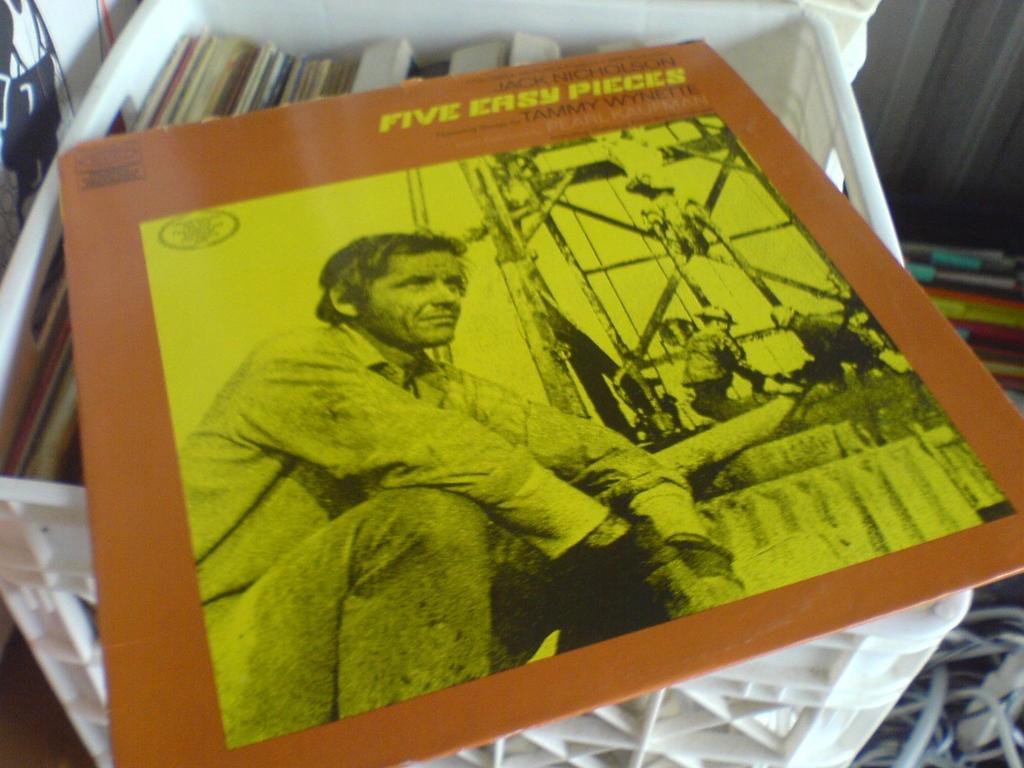Describe this image in one or two sentences. In the center of the picture there is a poster. At the bottom there is a basket, in a basket there are books and other objects. On the right there are cables and books. On the left there is a poster. 